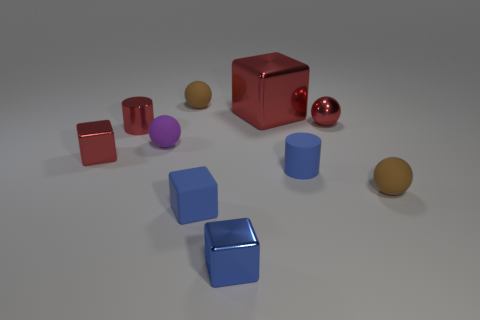Is there anything else that is the same size as the matte cube?
Offer a very short reply. Yes. How many red objects are to the left of the blue cylinder?
Provide a short and direct response. 3. Are there more small blue cubes than tiny blue shiny blocks?
Your answer should be very brief. Yes. There is a tiny brown object in front of the thing that is to the left of the tiny red metallic cylinder; what is its shape?
Keep it short and to the point. Sphere. Do the small rubber cylinder and the tiny matte block have the same color?
Offer a very short reply. Yes. Is the number of shiny objects to the right of the small purple thing greater than the number of small cyan rubber blocks?
Ensure brevity in your answer.  Yes. How many purple balls are behind the small brown object on the right side of the red shiny sphere?
Provide a succinct answer. 1. Is the material of the brown thing that is on the right side of the small blue metallic block the same as the red thing right of the big red object?
Provide a short and direct response. No. There is a tiny cube that is the same color as the big block; what material is it?
Offer a very short reply. Metal. How many red metallic objects are the same shape as the small purple object?
Keep it short and to the point. 1. 